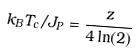<formula> <loc_0><loc_0><loc_500><loc_500>k _ { B } T _ { c } / J _ { P } = \frac { z } { 4 \ln ( 2 ) }</formula> 